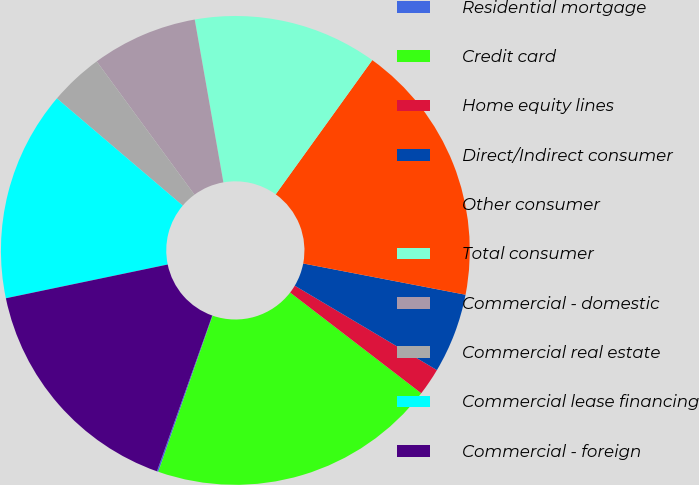Convert chart. <chart><loc_0><loc_0><loc_500><loc_500><pie_chart><fcel>Residential mortgage<fcel>Credit card<fcel>Home equity lines<fcel>Direct/Indirect consumer<fcel>Other consumer<fcel>Total consumer<fcel>Commercial - domestic<fcel>Commercial real estate<fcel>Commercial lease financing<fcel>Commercial - foreign<nl><fcel>0.1%<fcel>19.9%<fcel>1.9%<fcel>5.5%<fcel>18.1%<fcel>12.7%<fcel>7.3%<fcel>3.7%<fcel>14.5%<fcel>16.3%<nl></chart> 